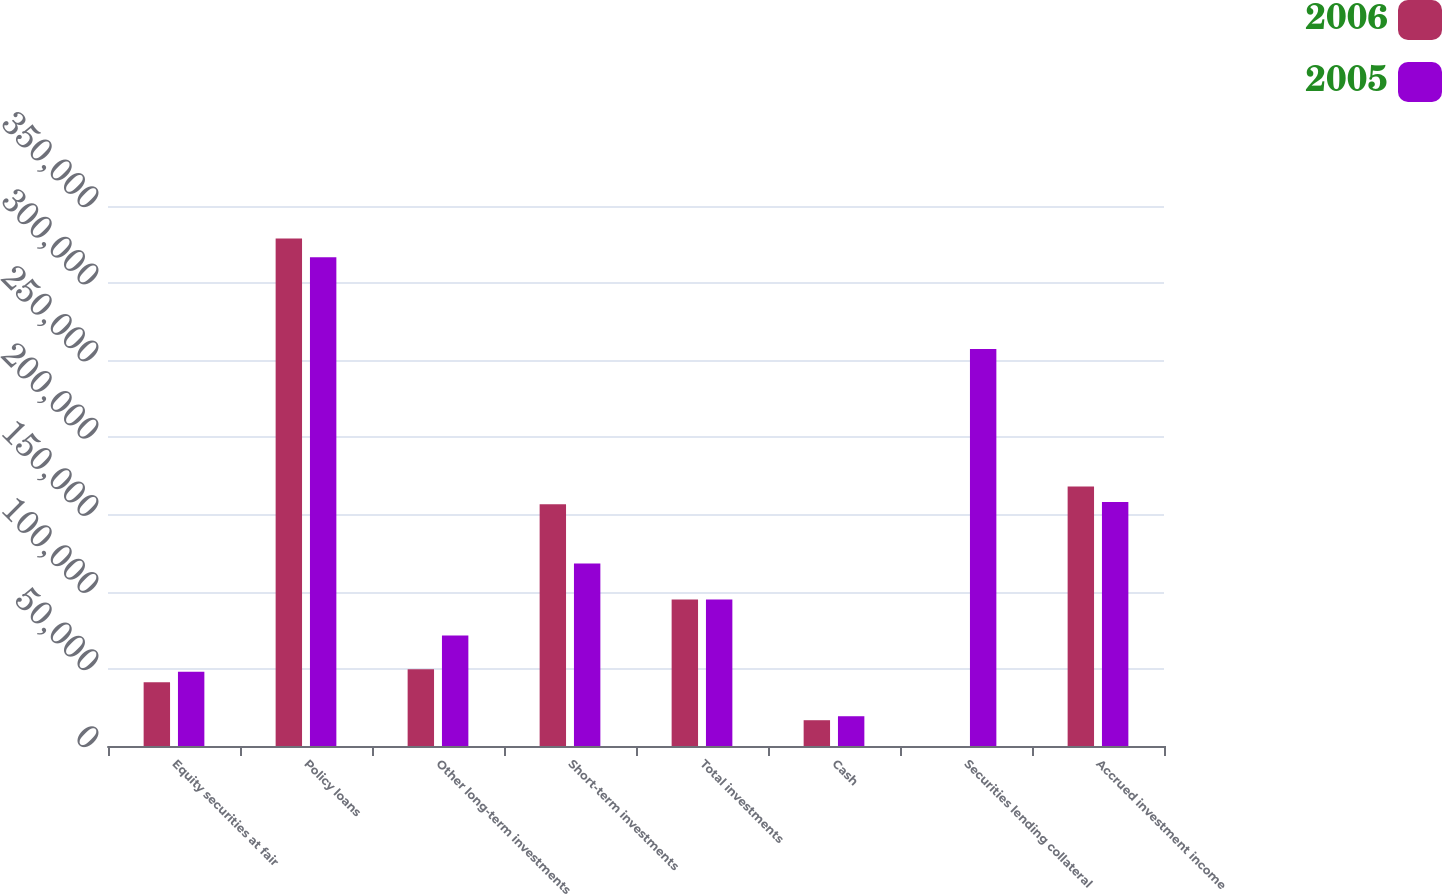<chart> <loc_0><loc_0><loc_500><loc_500><stacked_bar_chart><ecel><fcel>Equity securities at fair<fcel>Policy loans<fcel>Other long-term investments<fcel>Short-term investments<fcel>Total investments<fcel>Cash<fcel>Securities lending collateral<fcel>Accrued investment income<nl><fcel>2006<fcel>41245<fcel>328891<fcel>49681<fcel>156671<fcel>94940<fcel>16716<fcel>0<fcel>168118<nl><fcel>2005<fcel>48047<fcel>316829<fcel>71570<fcel>118310<fcel>94940<fcel>19297<fcel>257390<fcel>158225<nl></chart> 